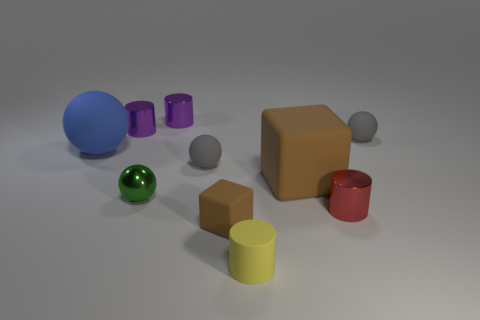How big is the rubber thing that is both in front of the blue sphere and on the right side of the small yellow object?
Offer a terse response. Large. Do the rubber block behind the small green metallic thing and the rubber block that is in front of the tiny red shiny thing have the same color?
Your answer should be compact. Yes. Are there any yellow rubber cylinders that are left of the gray matte ball left of the tiny gray sphere behind the blue object?
Ensure brevity in your answer.  No. How many gray rubber objects are the same size as the green metal sphere?
Ensure brevity in your answer.  2. What is the ball in front of the tiny rubber sphere on the left side of the red cylinder made of?
Your answer should be compact. Metal. There is a gray rubber thing on the left side of the small matte ball to the right of the small cylinder that is to the right of the yellow rubber object; what is its shape?
Offer a terse response. Sphere. Does the brown object that is in front of the large brown matte block have the same shape as the brown matte thing that is behind the tiny brown rubber thing?
Your answer should be compact. Yes. What number of other objects are the same material as the big sphere?
Offer a terse response. 5. What is the shape of the tiny yellow object that is made of the same material as the large ball?
Give a very brief answer. Cylinder. Is the rubber cylinder the same size as the blue matte object?
Ensure brevity in your answer.  No. 